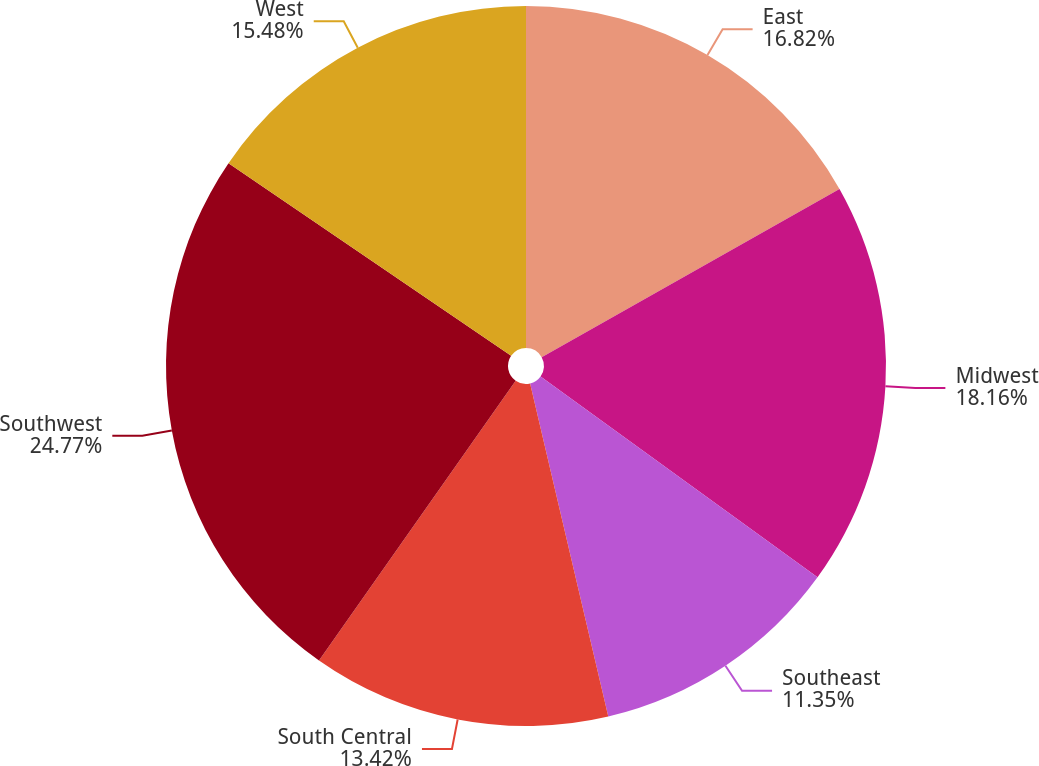Convert chart to OTSL. <chart><loc_0><loc_0><loc_500><loc_500><pie_chart><fcel>East<fcel>Midwest<fcel>Southeast<fcel>South Central<fcel>Southwest<fcel>West<nl><fcel>16.82%<fcel>18.16%<fcel>11.35%<fcel>13.42%<fcel>24.77%<fcel>15.48%<nl></chart> 